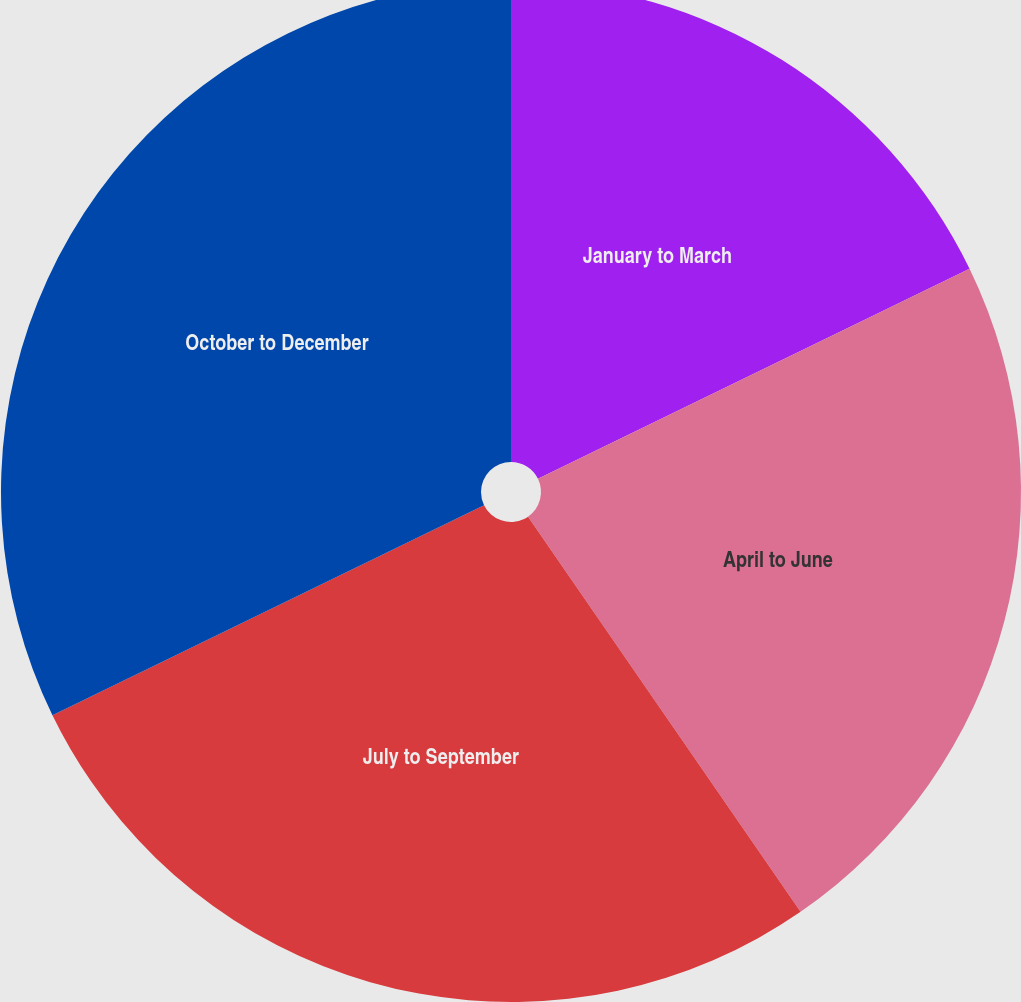Convert chart. <chart><loc_0><loc_0><loc_500><loc_500><pie_chart><fcel>January to March<fcel>April to June<fcel>July to September<fcel>October to December<nl><fcel>17.79%<fcel>22.6%<fcel>27.4%<fcel>32.21%<nl></chart> 